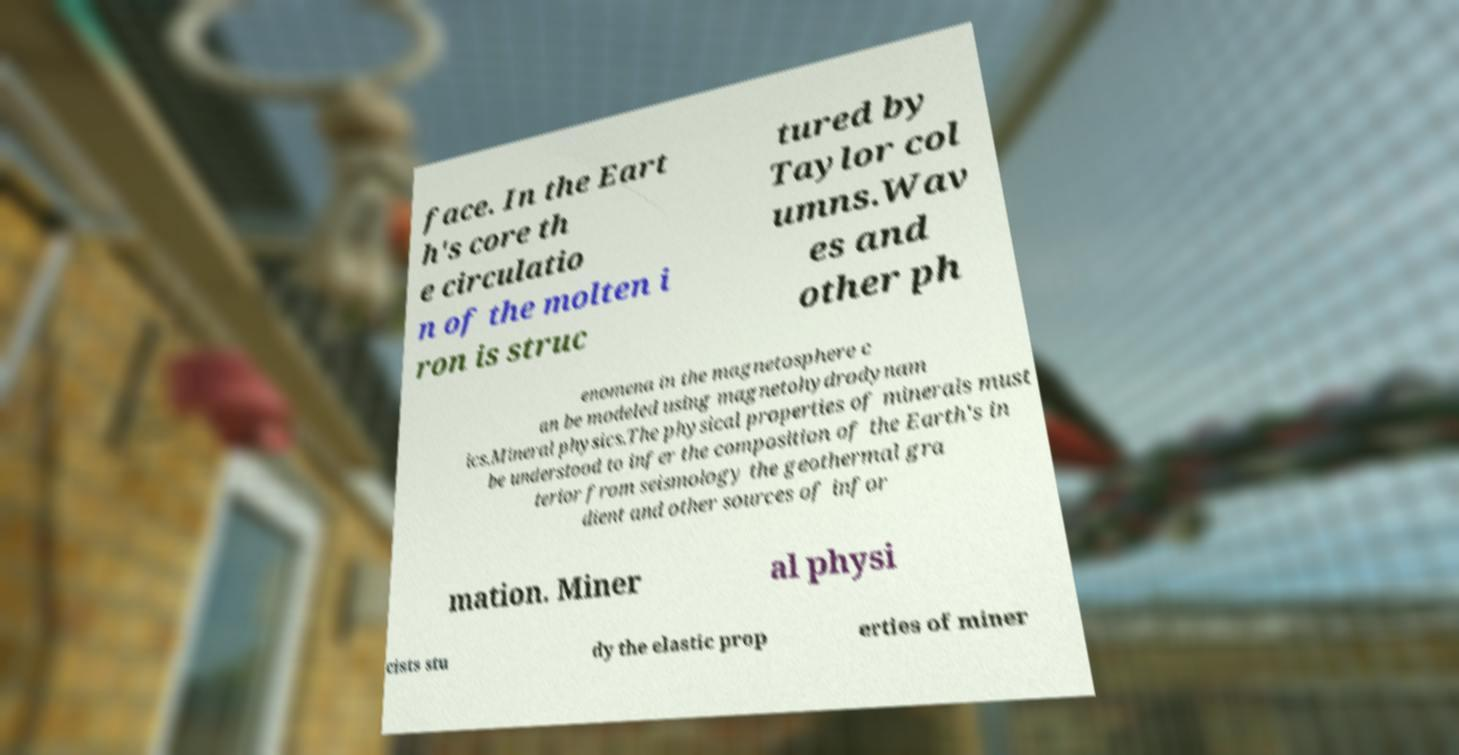Please identify and transcribe the text found in this image. face. In the Eart h's core th e circulatio n of the molten i ron is struc tured by Taylor col umns.Wav es and other ph enomena in the magnetosphere c an be modeled using magnetohydrodynam ics.Mineral physics.The physical properties of minerals must be understood to infer the composition of the Earth's in terior from seismology the geothermal gra dient and other sources of infor mation. Miner al physi cists stu dy the elastic prop erties of miner 